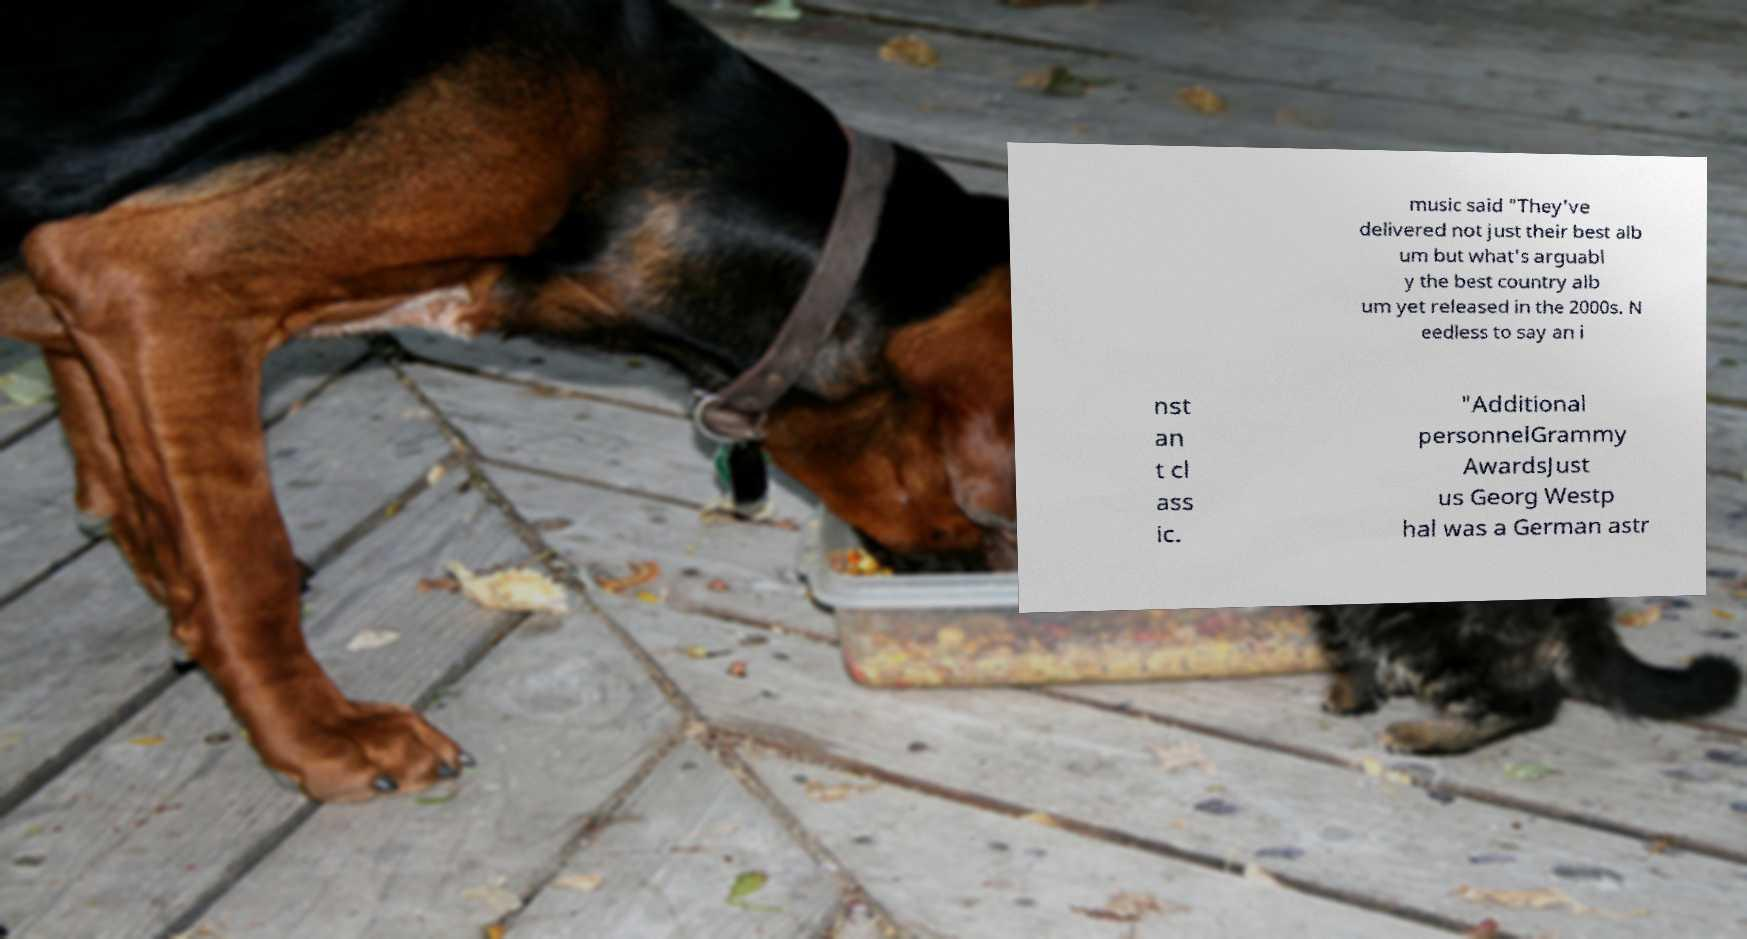Can you accurately transcribe the text from the provided image for me? music said "They've delivered not just their best alb um but what's arguabl y the best country alb um yet released in the 2000s. N eedless to say an i nst an t cl ass ic. "Additional personnelGrammy AwardsJust us Georg Westp hal was a German astr 